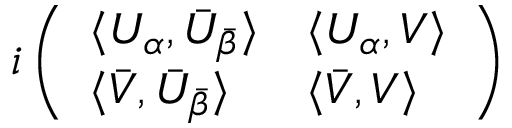Convert formula to latex. <formula><loc_0><loc_0><loc_500><loc_500>i \left ( \begin{array} { l l } { { \langle U _ { \alpha } , \bar { U } _ { \bar { \beta } } \rangle } } & { { \langle U _ { \alpha } , V \rangle } } \\ { { \langle \bar { V } , \bar { U } _ { \bar { \beta } } \rangle } } & { { \langle \bar { V } , V \rangle } } \end{array} \right )</formula> 